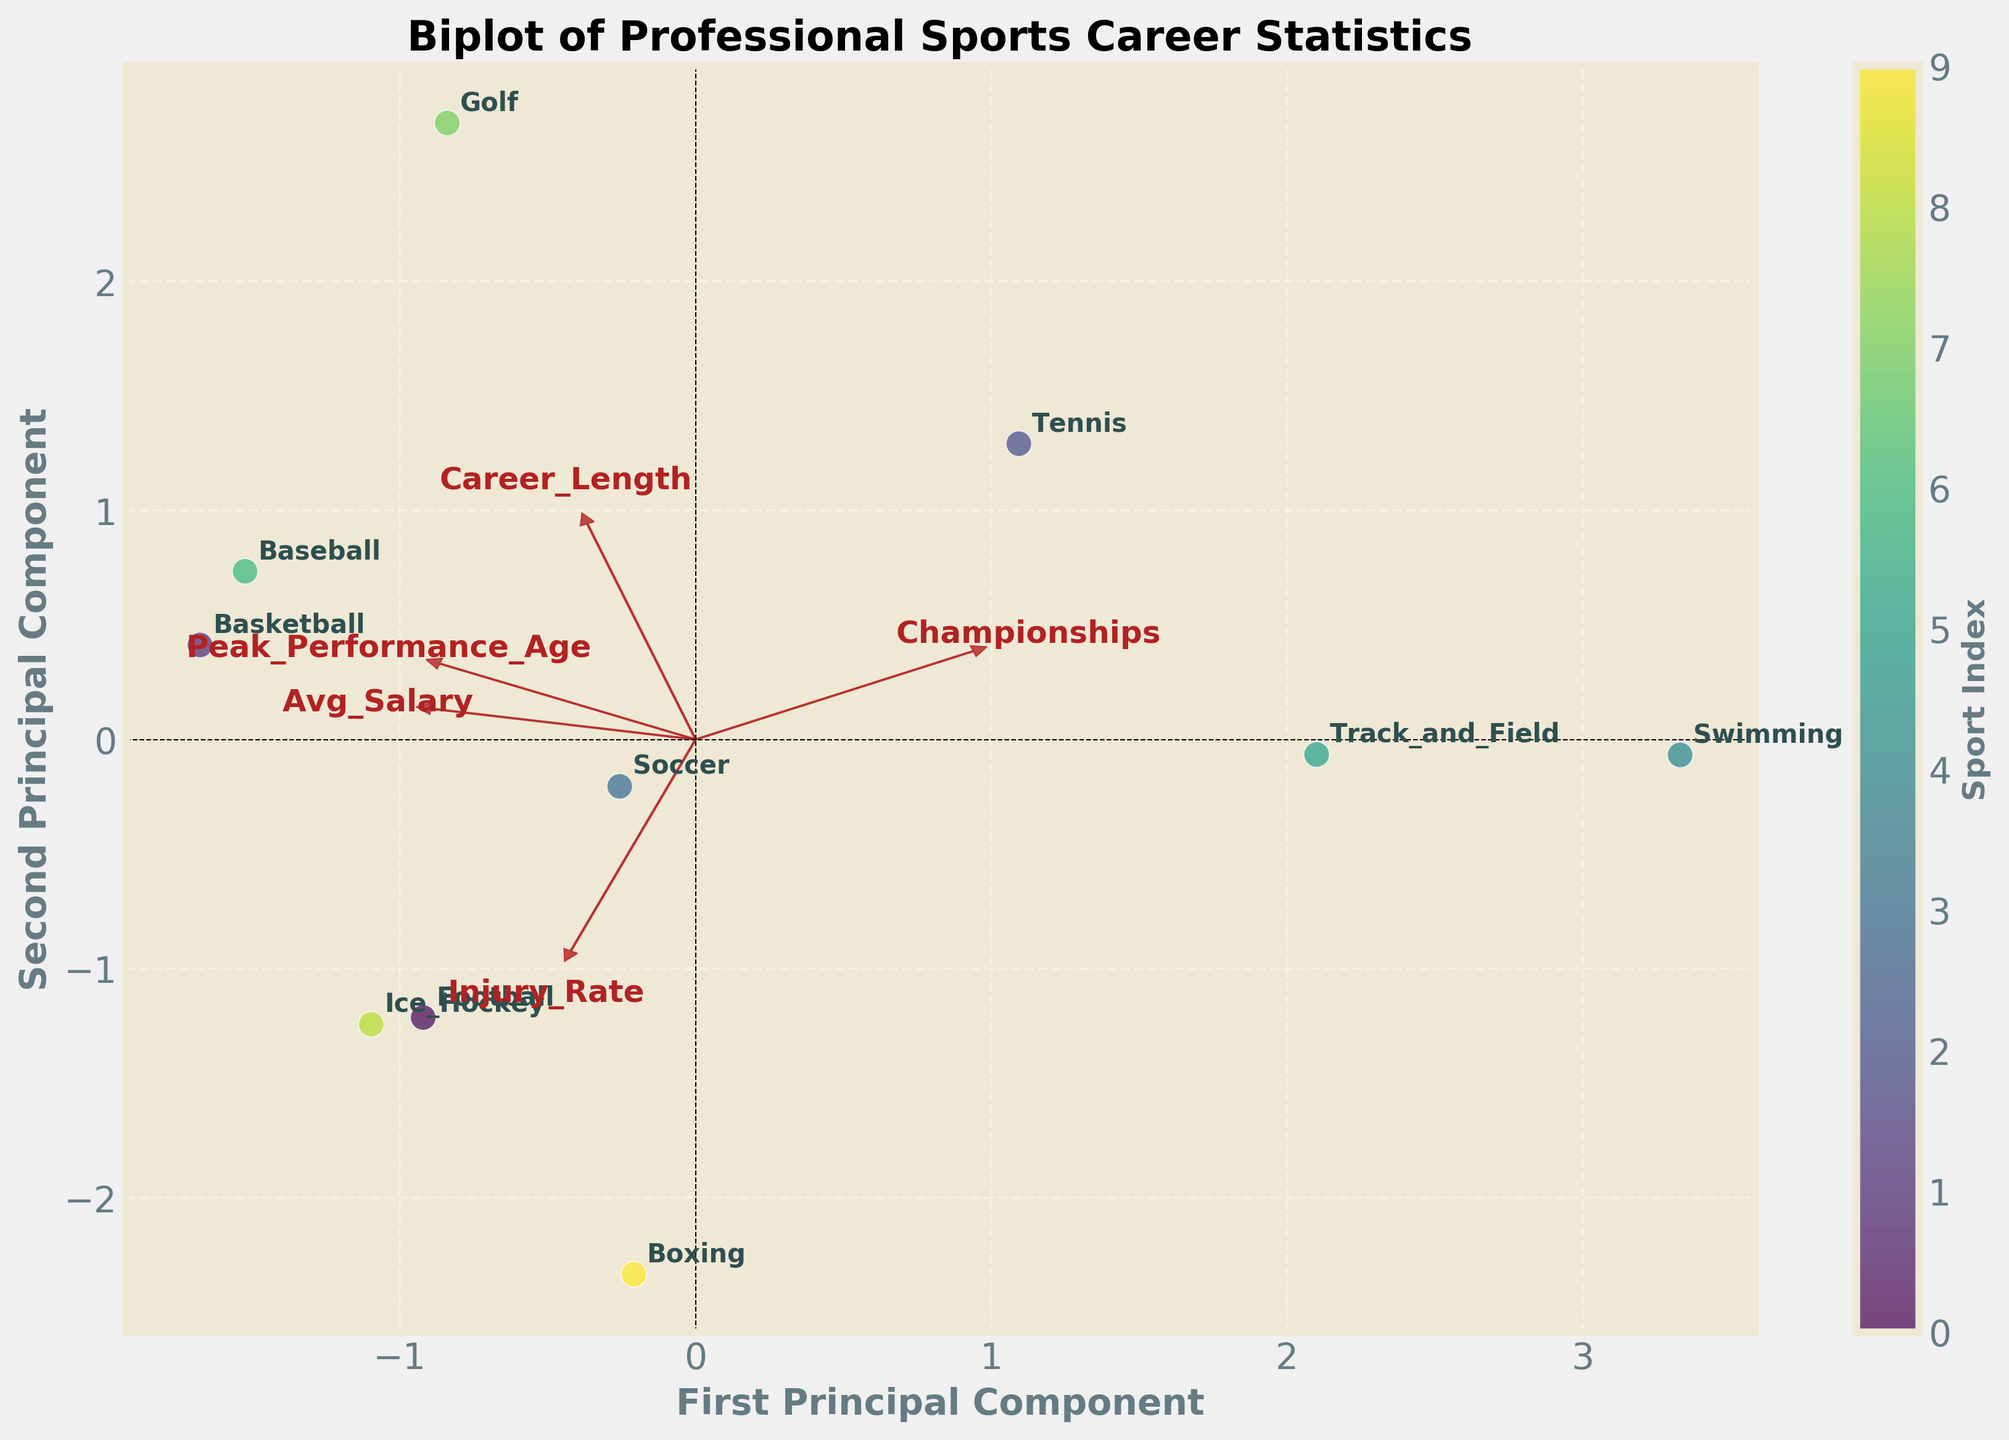How many sports are represented in the biplot? Count the number of unique data points (labels) on the plot. Each label represents a different sport.
Answer: 10 Which sport has the shortest career length according to the biplot? Locate the data points on the biplot and identify the sport with the smallest value along the 'Career Length' axis. This sport will be positioned lowest on the plot.
Answer: Boxing Which two features are represented by the longest vectors in the biplot? Examine the arrows (loadings) plotted from the origin. Identify the two vectors with the greatest length by visual comparison.
Answer: Avg_Salary and Career_Length What relationship is suggested between Avg_Salary and Career Length in the biplot? Observe the direction and proximity of the vectors for Avg_Salary and Career_Length. If they are pointing in similar directions, it suggests a positive correlation between the two features.
Answer: Positive correlation Which sport has a peak performance age closest to 32 according to the biplot? Locate the data points and identify the one closest to the value which corresponds to an age of 32 on the 'Peak Performance Age' axis.
Answer: Golf Between Basketball and Soccer, which sport appears to have a higher average salary based on the plot? Find the data points for Basketball and Soccer and compare their positions relative to the 'Avg_Salary' vector. The sport positioned closer to the arrow in the positive direction has a higher average salary.
Answer: Basketball Is there a sport that stands out for its lower injury rate on the biplot? Identify which sport is closest to the 'Injury_Rate' vector pointing in the lower direction, indicating a smaller injury rate.
Answer: Golf Which principal component explains more variance in the data according to the biplot, the first or the second? Identify by examining the labels next to each principal component. The one with the larger corresponding variance will explain more variance in the data.
Answer: First Principal Component What do the colors represent in the biplot? The colors correspond to different sports indexed by different colors to visually differentiate between them. You can confirm this by looking at the color gradient bar and matching it to the data points.
Answer: Sport Index 